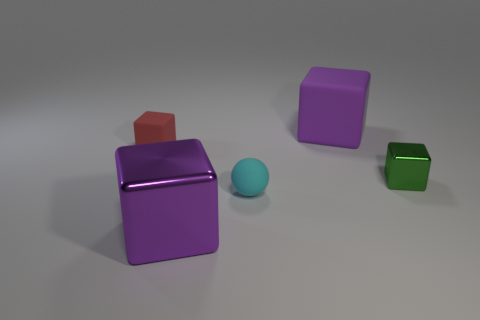There is a purple matte object; is its size the same as the matte block that is on the left side of the large metal block?
Your response must be concise. No. How many other things are there of the same color as the small ball?
Keep it short and to the point. 0. Are there any tiny cyan matte balls on the left side of the tiny cyan thing?
Your answer should be compact. No. What number of things are big rubber cubes or things that are behind the tiny rubber block?
Ensure brevity in your answer.  1. There is a purple cube that is left of the tiny cyan object; is there a red rubber block behind it?
Keep it short and to the point. Yes. What shape is the large object behind the large purple cube in front of the large purple rubber cube to the right of the small red thing?
Keep it short and to the point. Cube. The cube that is both to the left of the big rubber cube and behind the big shiny block is what color?
Provide a succinct answer. Red. There is a metal thing that is right of the purple metal object; what shape is it?
Ensure brevity in your answer.  Cube. What is the shape of the small cyan object that is made of the same material as the tiny red thing?
Your answer should be very brief. Sphere. What number of rubber objects are either blocks or large cyan cylinders?
Keep it short and to the point. 2. 